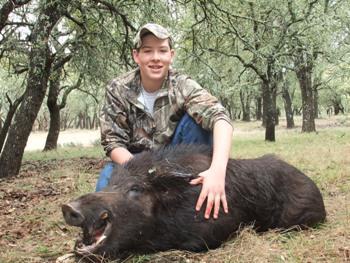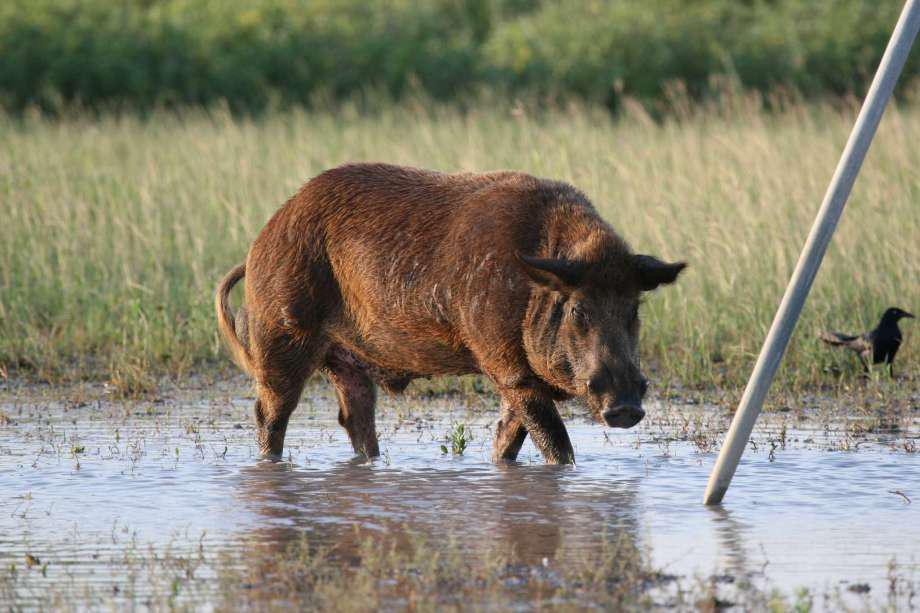The first image is the image on the left, the second image is the image on the right. Examine the images to the left and right. Is the description "there is a person crouched down behind a dead boar on brown grass" accurate? Answer yes or no. Yes. The first image is the image on the left, the second image is the image on the right. Assess this claim about the two images: "In at least one image there is a person kneeing over a dead boar with its mouth hanging open.". Correct or not? Answer yes or no. Yes. 